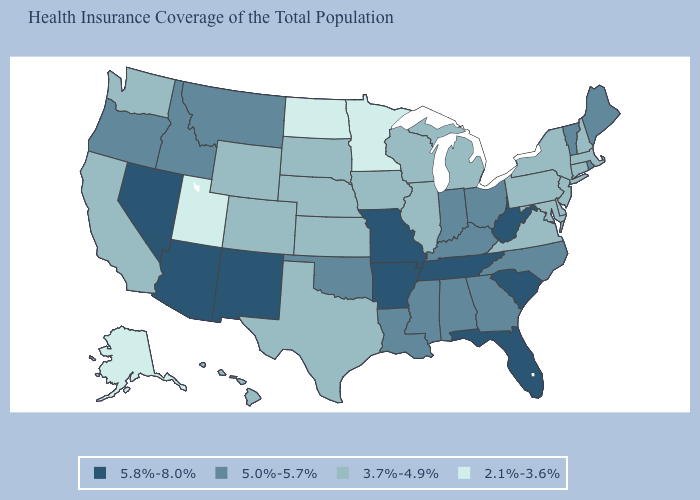Does Alabama have a higher value than New York?
Write a very short answer. Yes. Which states have the highest value in the USA?
Short answer required. Arizona, Arkansas, Florida, Missouri, Nevada, New Mexico, South Carolina, Tennessee, West Virginia. What is the value of Connecticut?
Concise answer only. 3.7%-4.9%. Which states have the lowest value in the South?
Concise answer only. Delaware, Maryland, Texas, Virginia. Does the first symbol in the legend represent the smallest category?
Write a very short answer. No. Does the first symbol in the legend represent the smallest category?
Concise answer only. No. Among the states that border Missouri , which have the highest value?
Concise answer only. Arkansas, Tennessee. What is the value of Nevada?
Write a very short answer. 5.8%-8.0%. Among the states that border New Mexico , does Utah have the lowest value?
Be succinct. Yes. What is the highest value in the USA?
Short answer required. 5.8%-8.0%. What is the highest value in the Northeast ?
Short answer required. 5.0%-5.7%. Does Georgia have the same value as Indiana?
Give a very brief answer. Yes. Which states have the lowest value in the USA?
Be succinct. Alaska, Minnesota, North Dakota, Utah. Does Nevada have a lower value than Michigan?
Keep it brief. No. Does Hawaii have the same value as Utah?
Write a very short answer. No. 